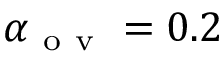<formula> <loc_0><loc_0><loc_500><loc_500>\alpha _ { o v } = 0 . 2</formula> 